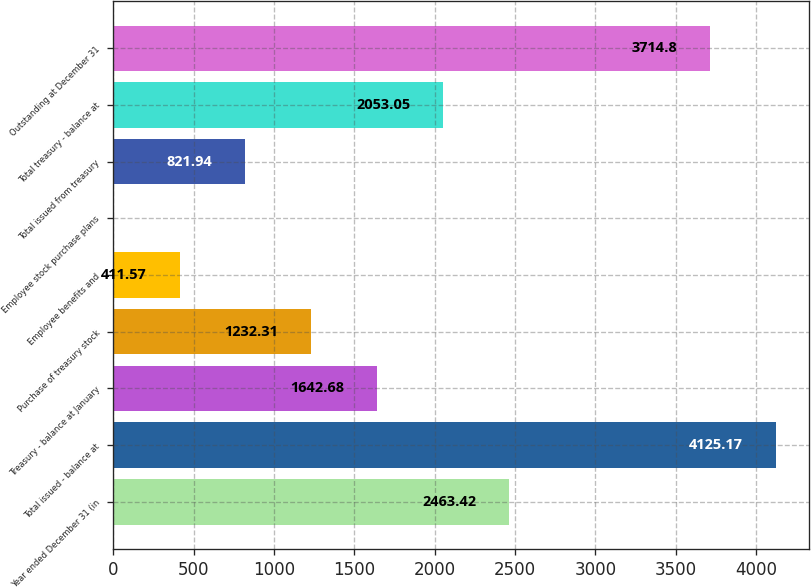<chart> <loc_0><loc_0><loc_500><loc_500><bar_chart><fcel>Year ended December 31 (in<fcel>Total issued - balance at<fcel>Treasury - balance at January<fcel>Purchase of treasury stock<fcel>Employee benefits and<fcel>Employee stock purchase plans<fcel>Total issued from treasury<fcel>Total treasury - balance at<fcel>Outstanding at December 31<nl><fcel>2463.42<fcel>4125.17<fcel>1642.68<fcel>1232.31<fcel>411.57<fcel>1.2<fcel>821.94<fcel>2053.05<fcel>3714.8<nl></chart> 